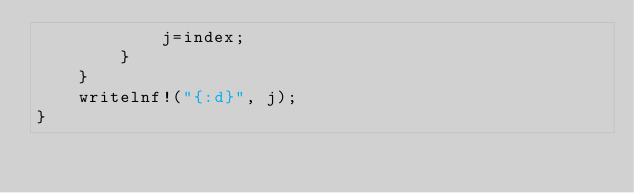Convert code to text. <code><loc_0><loc_0><loc_500><loc_500><_Rust_>            j=index;
        }
    }
    writelnf!("{:d}", j);
}</code> 